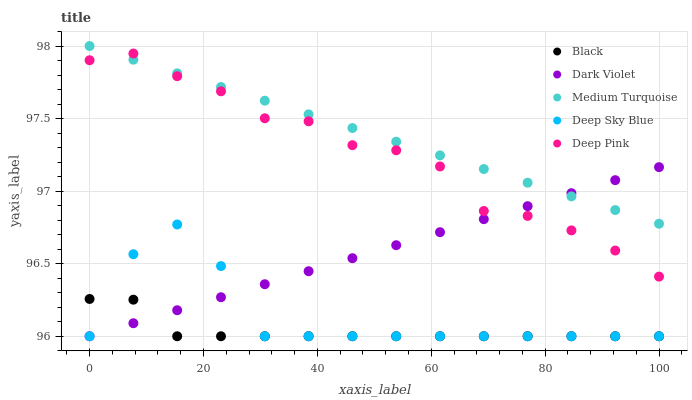Does Black have the minimum area under the curve?
Answer yes or no. Yes. Does Medium Turquoise have the maximum area under the curve?
Answer yes or no. Yes. Does Deep Pink have the minimum area under the curve?
Answer yes or no. No. Does Deep Pink have the maximum area under the curve?
Answer yes or no. No. Is Dark Violet the smoothest?
Answer yes or no. Yes. Is Deep Sky Blue the roughest?
Answer yes or no. Yes. Is Deep Pink the smoothest?
Answer yes or no. No. Is Deep Pink the roughest?
Answer yes or no. No. Does Deep Sky Blue have the lowest value?
Answer yes or no. Yes. Does Deep Pink have the lowest value?
Answer yes or no. No. Does Medium Turquoise have the highest value?
Answer yes or no. Yes. Does Deep Pink have the highest value?
Answer yes or no. No. Is Deep Sky Blue less than Deep Pink?
Answer yes or no. Yes. Is Medium Turquoise greater than Deep Sky Blue?
Answer yes or no. Yes. Does Dark Violet intersect Medium Turquoise?
Answer yes or no. Yes. Is Dark Violet less than Medium Turquoise?
Answer yes or no. No. Is Dark Violet greater than Medium Turquoise?
Answer yes or no. No. Does Deep Sky Blue intersect Deep Pink?
Answer yes or no. No. 